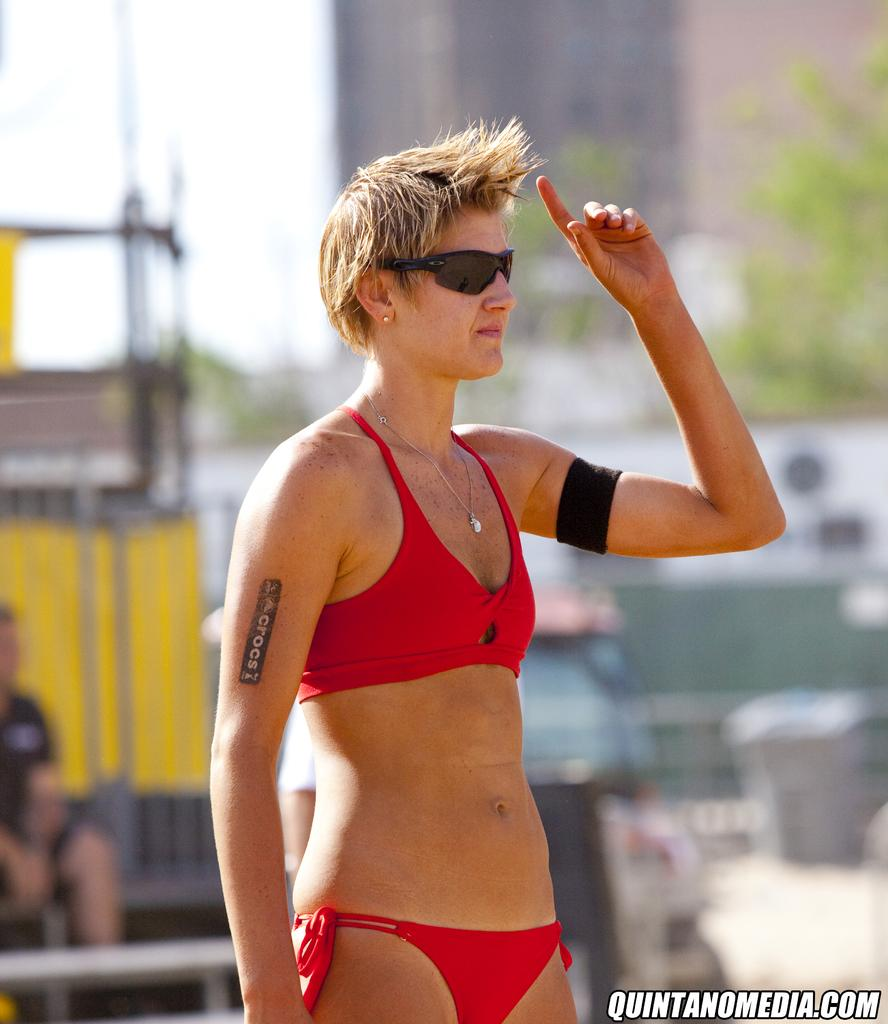Who is the main subject in the image? There is a woman in the image. What is the woman wearing on her head? The woman is wearing a band. What type of eyewear is the woman wearing? The woman is wearing goggles. What is the woman's posture in the image? The woman is standing. What can be seen in the background of the image? There are trees, a person, and some objects in the background of the image. How would you describe the image's quality? The image is blurry. What type of fang can be seen in the woman's mouth in the image? There is no fang visible in the woman's mouth in the image. What ornament is hanging from the tree in the background of the image? There is no ornament hanging from the tree in the background of the image. 